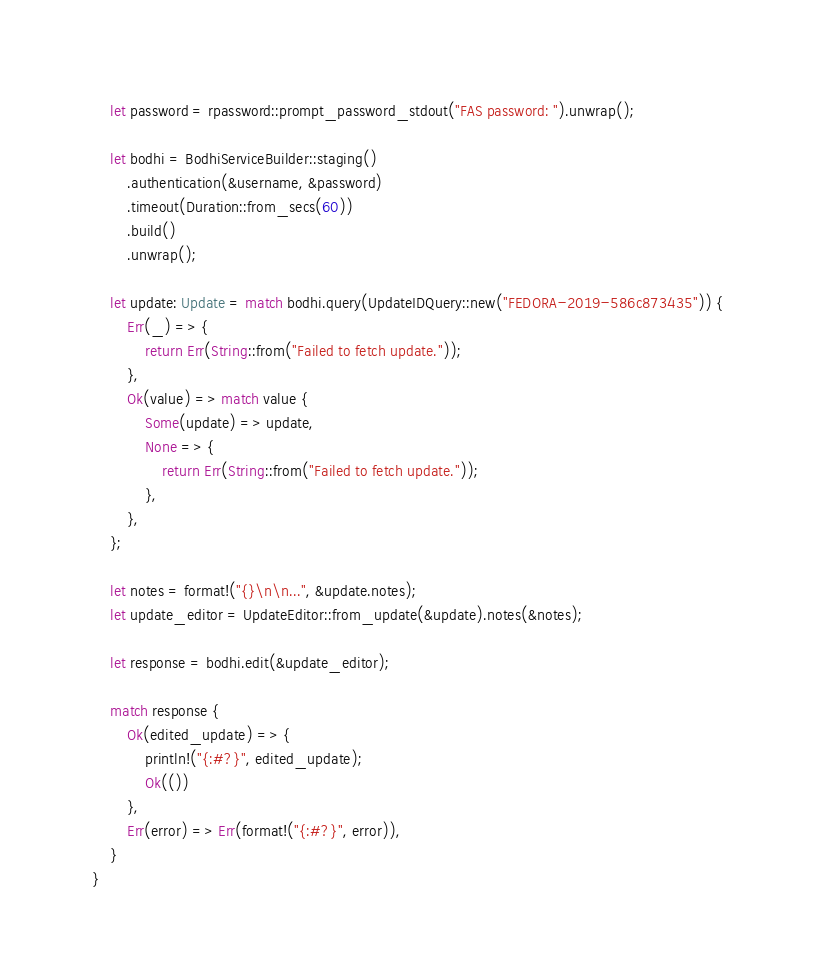Convert code to text. <code><loc_0><loc_0><loc_500><loc_500><_Rust_>    let password = rpassword::prompt_password_stdout("FAS password: ").unwrap();

    let bodhi = BodhiServiceBuilder::staging()
        .authentication(&username, &password)
        .timeout(Duration::from_secs(60))
        .build()
        .unwrap();

    let update: Update = match bodhi.query(UpdateIDQuery::new("FEDORA-2019-586c873435")) {
        Err(_) => {
            return Err(String::from("Failed to fetch update."));
        },
        Ok(value) => match value {
            Some(update) => update,
            None => {
                return Err(String::from("Failed to fetch update."));
            },
        },
    };

    let notes = format!("{}\n\n...", &update.notes);
    let update_editor = UpdateEditor::from_update(&update).notes(&notes);

    let response = bodhi.edit(&update_editor);

    match response {
        Ok(edited_update) => {
            println!("{:#?}", edited_update);
            Ok(())
        },
        Err(error) => Err(format!("{:#?}", error)),
    }
}
</code> 